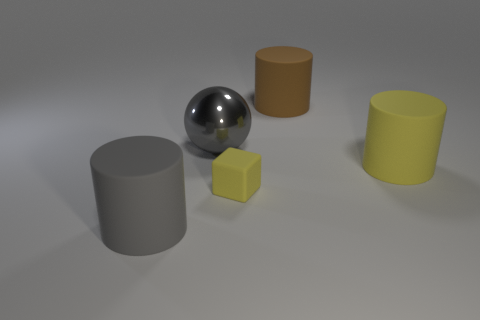Subtract all gray cylinders. How many cylinders are left? 2 Add 1 small yellow matte objects. How many objects exist? 6 Subtract all cylinders. How many objects are left? 2 Subtract all tiny things. Subtract all tiny green matte things. How many objects are left? 4 Add 1 small yellow matte objects. How many small yellow matte objects are left? 2 Add 2 tiny purple shiny things. How many tiny purple shiny things exist? 2 Subtract 0 cyan spheres. How many objects are left? 5 